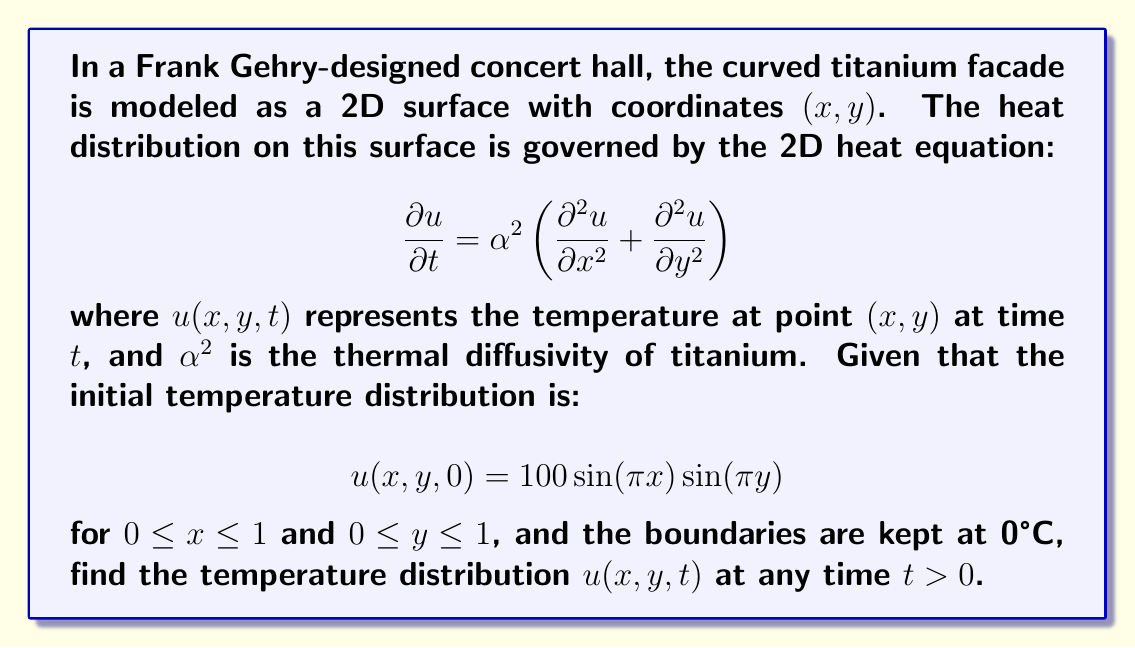Show me your answer to this math problem. To solve this problem, we'll use the method of separation of variables:

1) Assume a solution of the form: $u(x,y,t) = X(x)Y(y)T(t)$

2) Substituting into the heat equation:

   $$X(x)Y(y)T'(t) = \alpha^2[X''(x)Y(y)T(t) + X(x)Y''(y)T(t)]$$

3) Dividing by $\alpha^2X(x)Y(y)T(t)$:

   $$\frac{T'(t)}{\alpha^2T(t)} = \frac{X''(x)}{X(x)} + \frac{Y''(y)}{Y(y)} = -\lambda$$

   where $\lambda$ is a separation constant.

4) This gives us three ODEs:
   
   $T'(t) = -\alpha^2\lambda T(t)$
   $X''(x) = -\mu X(x)$
   $Y''(y) = -\nu Y(y)$
   
   where $\lambda = \mu + \nu$

5) Solving these ODEs with the boundary conditions:

   $X(x) = \sin(\pi x)$, $Y(y) = \sin(\pi y)$, $T(t) = e^{-2\alpha^2\pi^2t}$

6) The general solution is:

   $$u(x,y,t) = \sum_{m=1}^{\infty}\sum_{n=1}^{\infty}A_{mn}\sin(m\pi x)\sin(n\pi y)e^{-\alpha^2(m^2+n^2)\pi^2t}$$

7) Using the initial condition to find $A_{mn}$:

   $$100\sin(\pi x)\sin(\pi y) = \sum_{m=1}^{\infty}\sum_{n=1}^{\infty}A_{mn}\sin(m\pi x)\sin(n\pi y)$$

   This implies $A_{11} = 100$ and all other $A_{mn} = 0$

8) Therefore, the final solution is:

   $$u(x,y,t) = 100\sin(\pi x)\sin(\pi y)e^{-2\alpha^2\pi^2t}$$
Answer: $u(x,y,t) = 100\sin(\pi x)\sin(\pi y)e^{-2\alpha^2\pi^2t}$ 